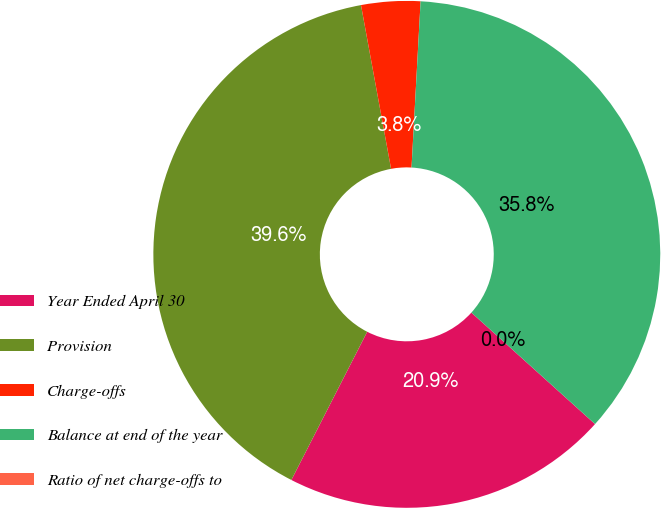<chart> <loc_0><loc_0><loc_500><loc_500><pie_chart><fcel>Year Ended April 30<fcel>Provision<fcel>Charge-offs<fcel>Balance at end of the year<fcel>Ratio of net charge-offs to<nl><fcel>20.85%<fcel>39.58%<fcel>3.76%<fcel>35.81%<fcel>0.0%<nl></chart> 